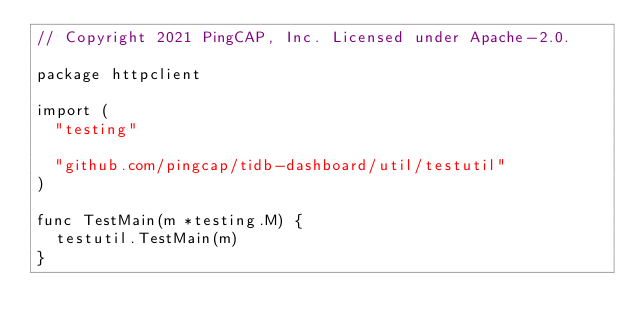<code> <loc_0><loc_0><loc_500><loc_500><_Go_>// Copyright 2021 PingCAP, Inc. Licensed under Apache-2.0.

package httpclient

import (
	"testing"

	"github.com/pingcap/tidb-dashboard/util/testutil"
)

func TestMain(m *testing.M) {
	testutil.TestMain(m)
}
</code> 